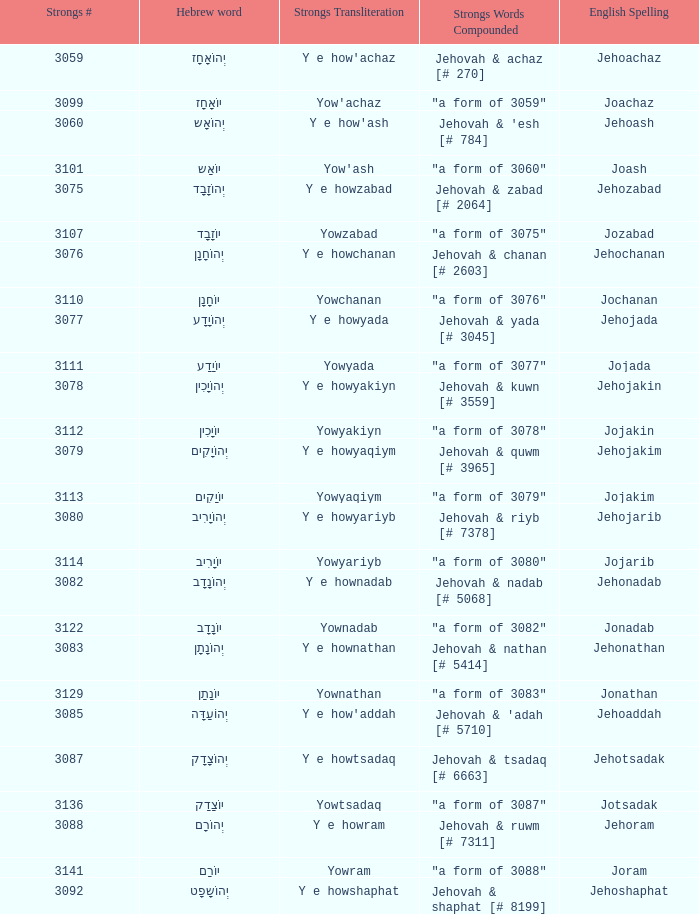What is the english representation of the word that possesses the strong's transliteration of y e howram? Jehoram. 